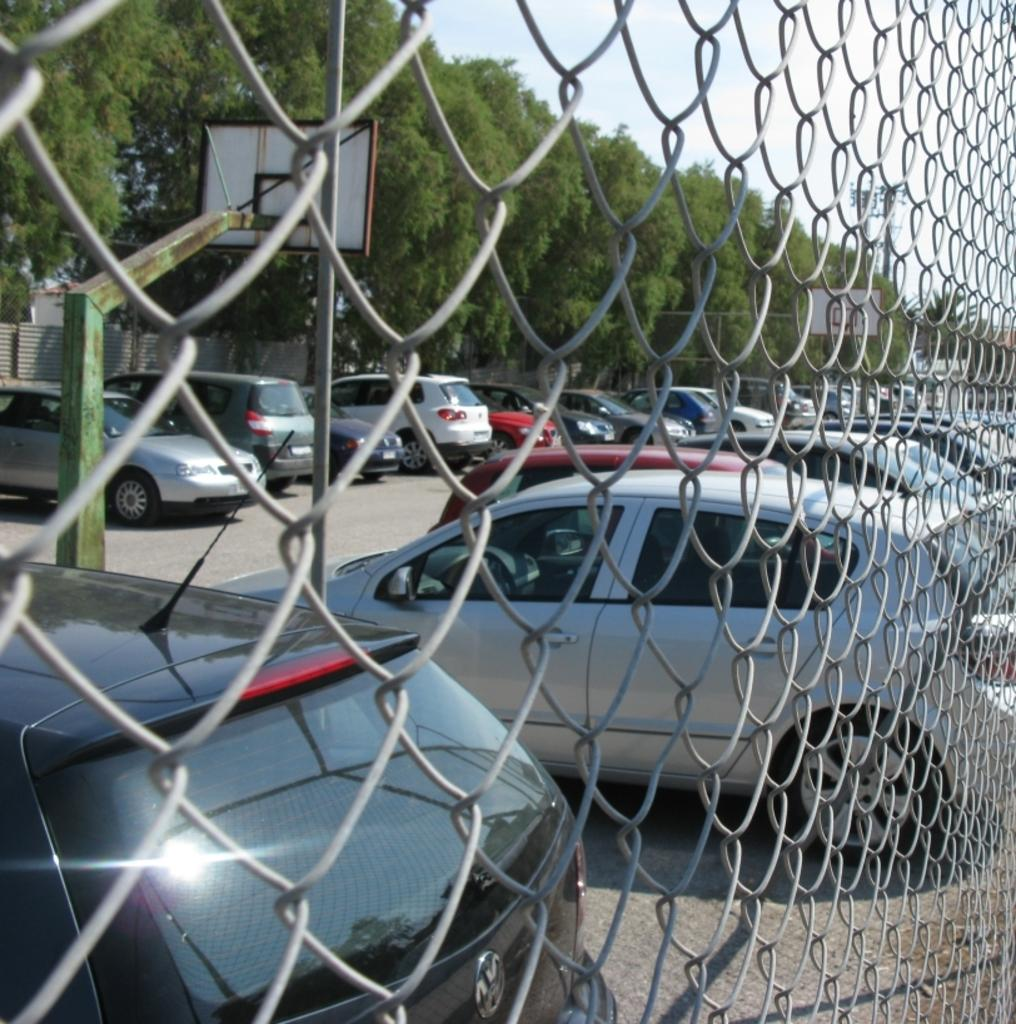What type of barrier can be seen in the image? There is a fence in the image. What else is present in the image besides the fence? There are vehicles and other objects in the image. What can be seen in the background of the image? There are trees in the background of the image. What is visible at the top of the image? The sky is visible at the top of the image. What type of pest can be seen crawling on the fence in the image? There is no pest visible on the fence in the image. Are there any dolls present in the image? There is no mention of dolls in the provided facts, and therefore, we cannot determine if dolls are present in the image. 